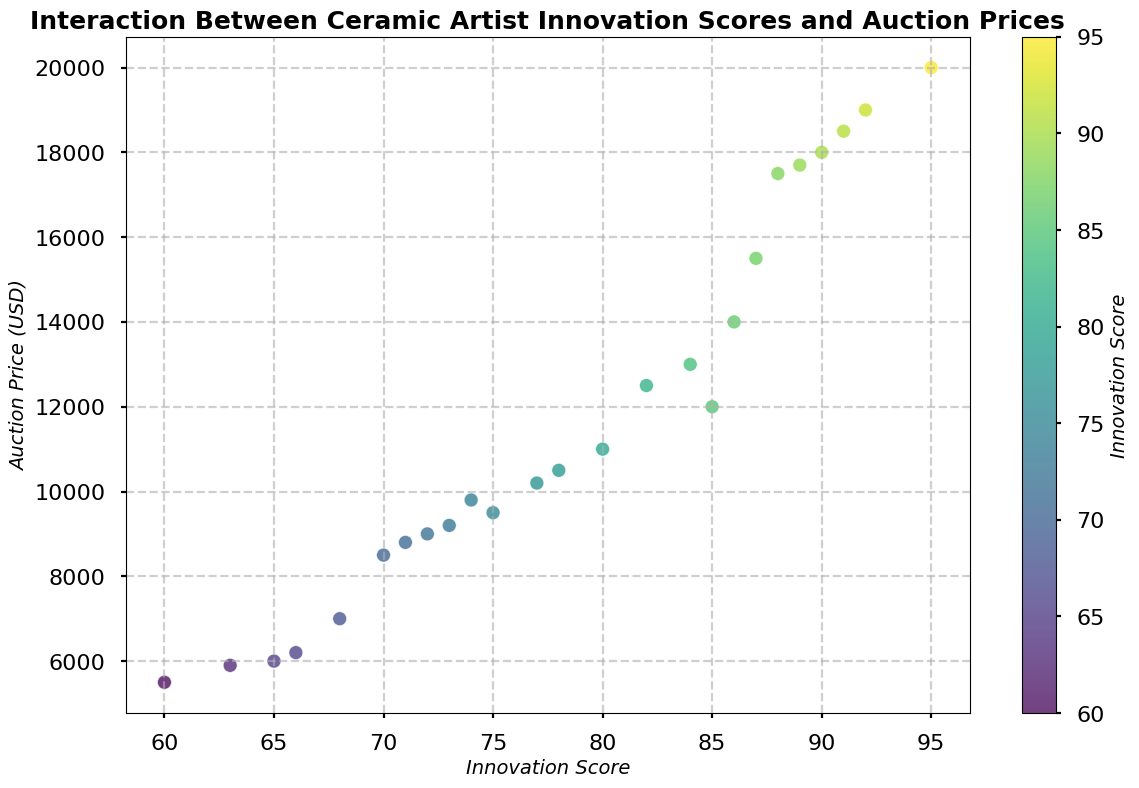How many data points represent auction prices above $15,000? First, identify the data points in the scatter plot with auction prices above $15,000. Count these points.
Answer: 7 Which innovation score corresponds to the highest auction price? Locate the highest point on the y-axis (auction price) in the scatter plot. See that it corresponds to the x-axis (innovation score) value of 95.
Answer: 95 Compare the lowest innovation score with the highest auction price. Which one is greater? The lowest innovation score is 60, and the highest auction price is $20,000. Compare these two values to see that $20,000 is greater than 60.
Answer: $20,000 What is the range of auction prices for innovation scores between 70 and 80? Identify the points with innovation scores between 70 and 80. Note their auction prices, which range from $8,500 to $11,000. Thus, the range is $11,000 - $8,500 = $2,500.
Answer: $2,500 Compare the average auction prices of artists with innovation scores above 85 and those with scores below 85. Which group has a higher average auction price? Calculate the average auction price for artists with scores above 85: (12500 + 18000 + 17500 + 20000 + 14000 + 17700 + 15500 + 18500 + 19000 = $153,700, divided by 9 = $17,077.78). For scores below 85: (5500 + 9500 + 8500 + 6000 + 11000 + 6200 + 10500 + 8000 + 9000 + 7000 + 10000 + 9800 = $107,500, divided by 10 = $10,750). The group with scores above 85 has a higher average auction price.
Answer: Above 85 How does the color gradient represent the innovation scores in the scatter plot? Look at the color gradient, which transitions from light to dark shades. The lighter colors represent lower innovation scores, and the darker colors represent higher innovation scores.
Answer: Gradient from light to dark Which data point is furthest from the trend line, considering both axes equally? Visually identify the point that is furthest from the main trend line in both innovation scores and auction prices. This might be subjective but typically you can see an outlier far from the general cluster, around (65, 6,000).
Answer: (65, 6,000) Plot the points with innovation scores of 90 or above and compare their average auction price. What do you get? Identify the points with innovation scores of 90, 91, 92, 88, 95, and 89. Their auction prices are 18000, 18500, 19000, 17500, 20000, 17700. Sum the prices: 18000 + 18500 + 19000 + 17500 + 20000 + 17700 = $111,700, divided by 6 = $18,616.67.
Answer: $18,616.67 